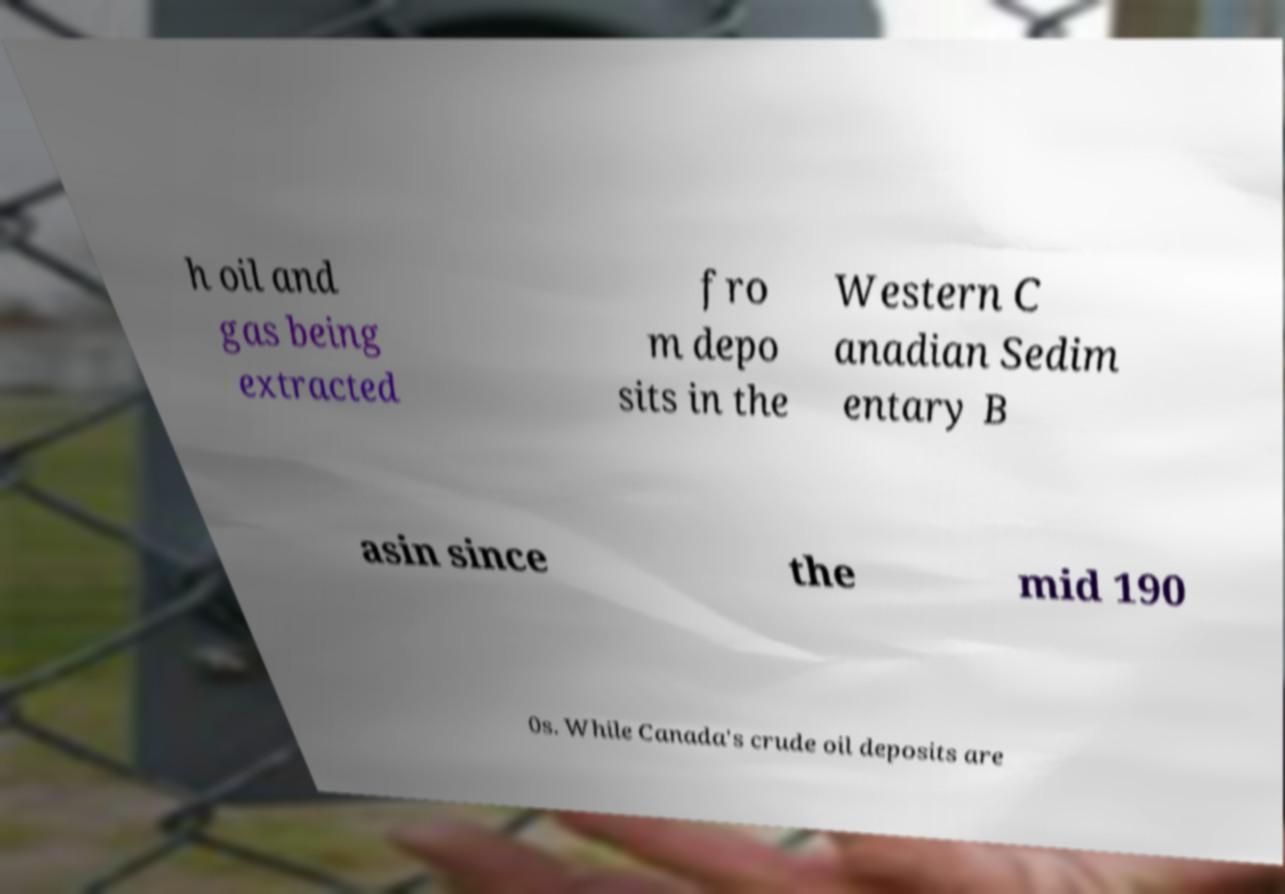For documentation purposes, I need the text within this image transcribed. Could you provide that? h oil and gas being extracted fro m depo sits in the Western C anadian Sedim entary B asin since the mid 190 0s. While Canada's crude oil deposits are 